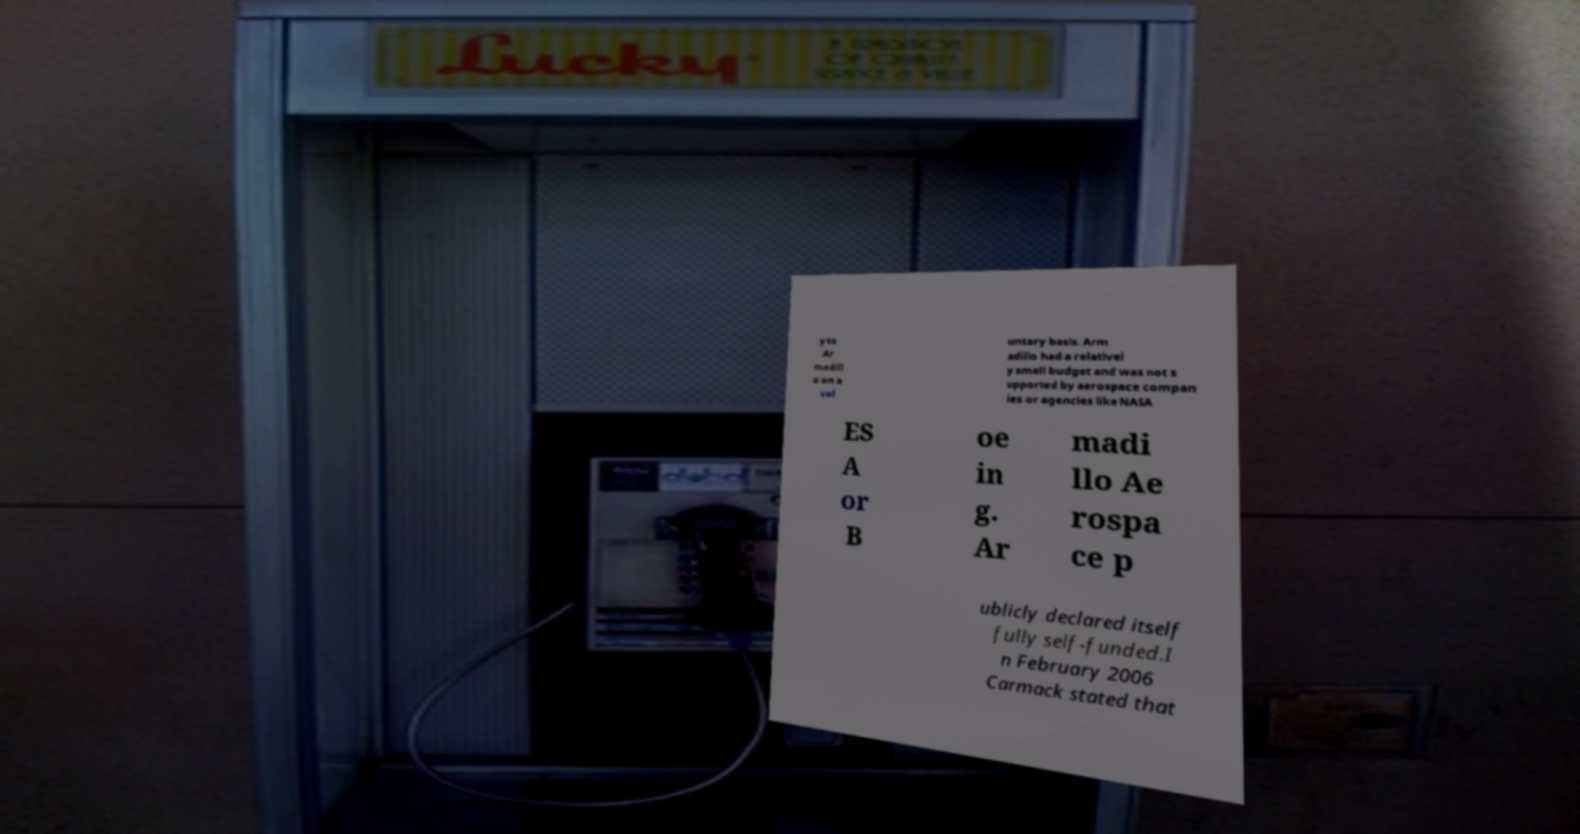Please read and relay the text visible in this image. What does it say? y to Ar madill o on a vol untary basis. Arm adillo had a relativel y small budget and was not s upported by aerospace compan ies or agencies like NASA ES A or B oe in g. Ar madi llo Ae rospa ce p ublicly declared itself fully self-funded.I n February 2006 Carmack stated that 